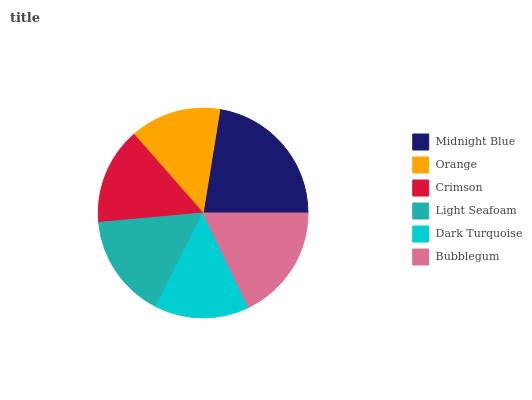Is Orange the minimum?
Answer yes or no. Yes. Is Midnight Blue the maximum?
Answer yes or no. Yes. Is Crimson the minimum?
Answer yes or no. No. Is Crimson the maximum?
Answer yes or no. No. Is Crimson greater than Orange?
Answer yes or no. Yes. Is Orange less than Crimson?
Answer yes or no. Yes. Is Orange greater than Crimson?
Answer yes or no. No. Is Crimson less than Orange?
Answer yes or no. No. Is Light Seafoam the high median?
Answer yes or no. Yes. Is Crimson the low median?
Answer yes or no. Yes. Is Midnight Blue the high median?
Answer yes or no. No. Is Midnight Blue the low median?
Answer yes or no. No. 